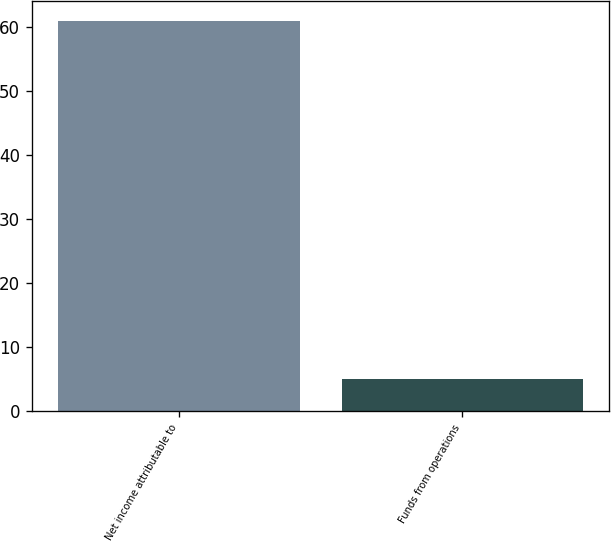<chart> <loc_0><loc_0><loc_500><loc_500><bar_chart><fcel>Net income attributable to<fcel>Funds from operations<nl><fcel>61<fcel>5<nl></chart> 